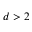Convert formula to latex. <formula><loc_0><loc_0><loc_500><loc_500>d > 2</formula> 